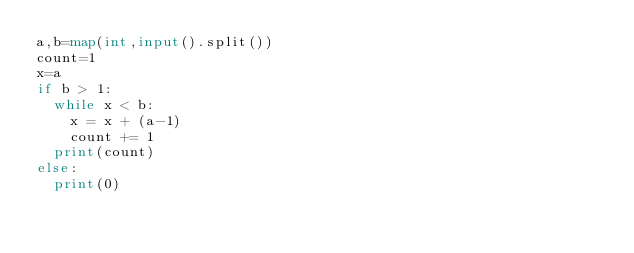<code> <loc_0><loc_0><loc_500><loc_500><_Python_>a,b=map(int,input().split())
count=1
x=a
if b > 1:
  while x < b:
    x = x + (a-1)
    count += 1
  print(count)
else:
  print(0)</code> 